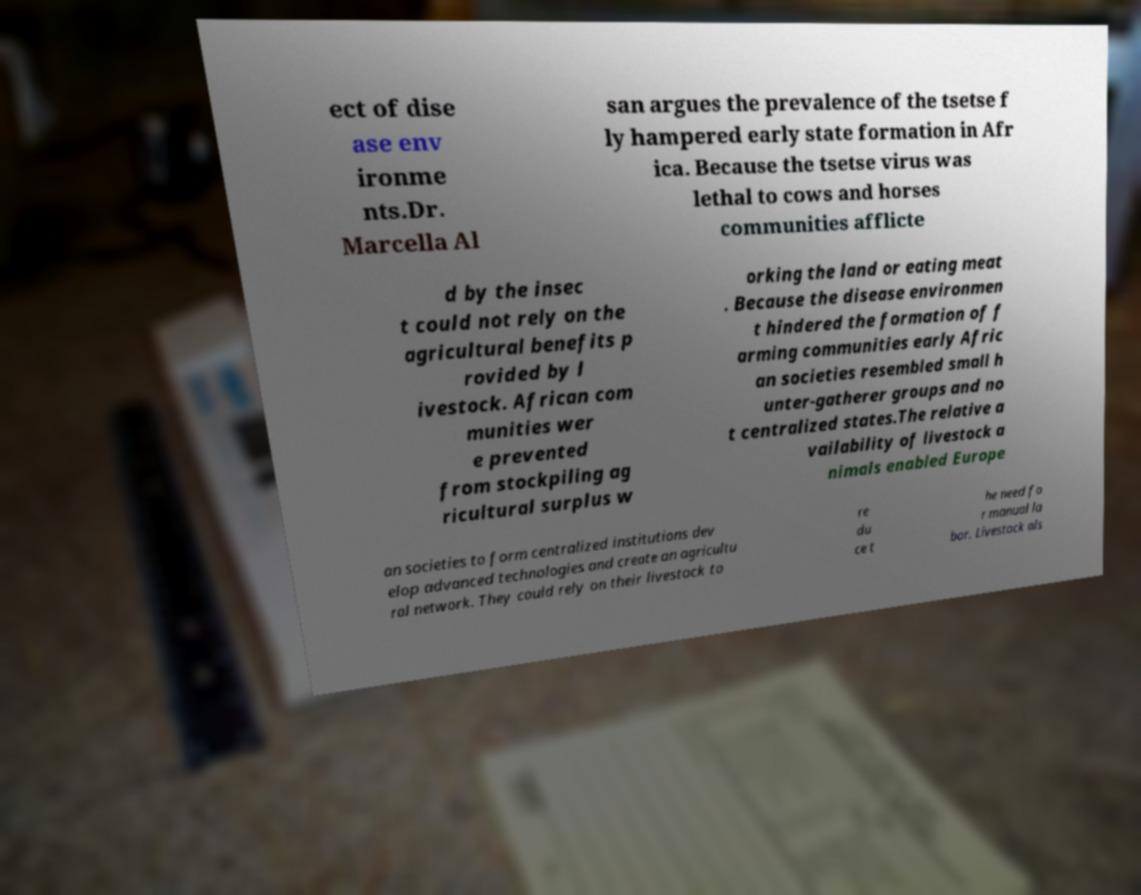Can you read and provide the text displayed in the image?This photo seems to have some interesting text. Can you extract and type it out for me? ect of dise ase env ironme nts.Dr. Marcella Al san argues the prevalence of the tsetse f ly hampered early state formation in Afr ica. Because the tsetse virus was lethal to cows and horses communities afflicte d by the insec t could not rely on the agricultural benefits p rovided by l ivestock. African com munities wer e prevented from stockpiling ag ricultural surplus w orking the land or eating meat . Because the disease environmen t hindered the formation of f arming communities early Afric an societies resembled small h unter-gatherer groups and no t centralized states.The relative a vailability of livestock a nimals enabled Europe an societies to form centralized institutions dev elop advanced technologies and create an agricultu ral network. They could rely on their livestock to re du ce t he need fo r manual la bor. Livestock als 